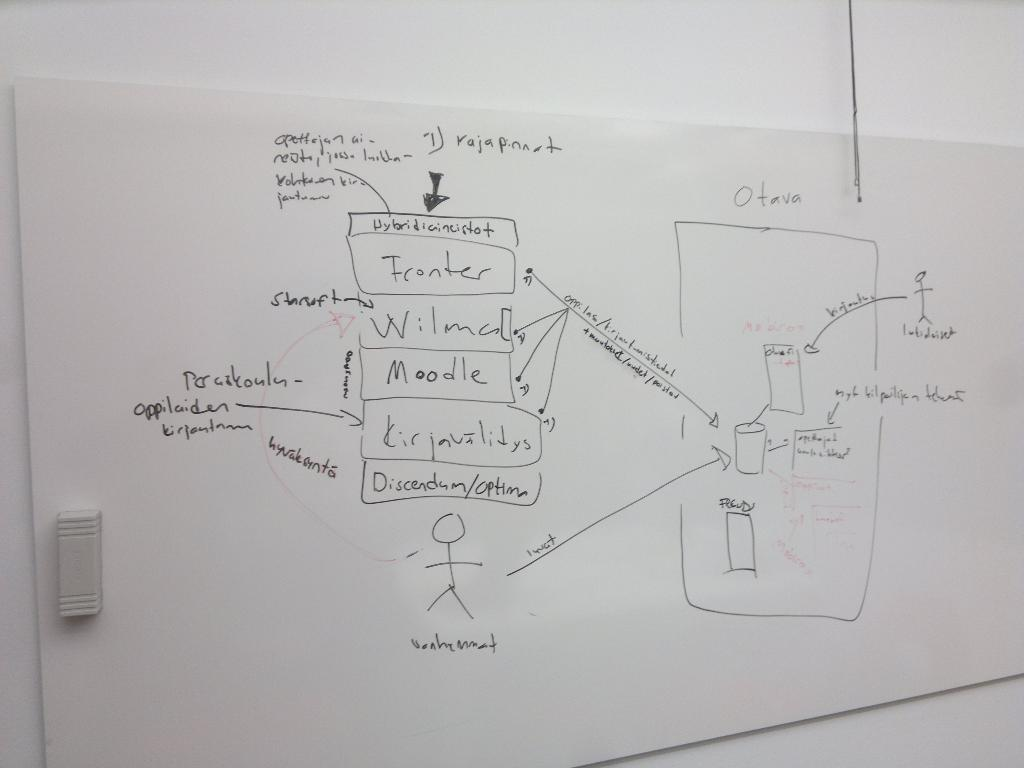<image>
Write a terse but informative summary of the picture. A white board that says Moodle on it. 